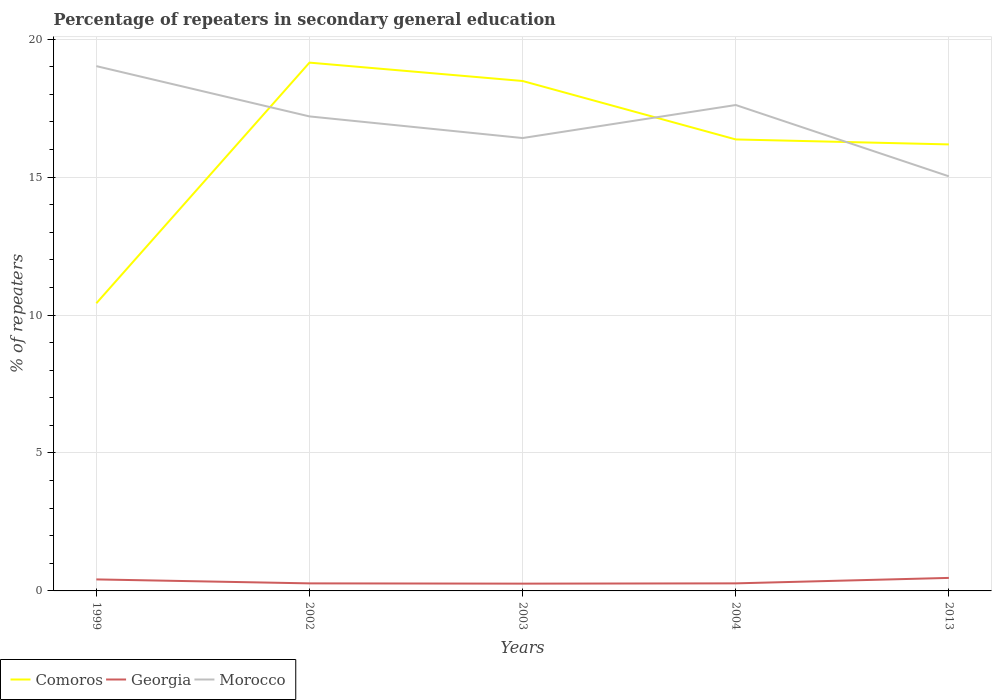Does the line corresponding to Georgia intersect with the line corresponding to Comoros?
Your response must be concise. No. Across all years, what is the maximum percentage of repeaters in secondary general education in Georgia?
Your answer should be compact. 0.26. What is the total percentage of repeaters in secondary general education in Georgia in the graph?
Provide a succinct answer. -0. What is the difference between the highest and the second highest percentage of repeaters in secondary general education in Georgia?
Make the answer very short. 0.21. How many years are there in the graph?
Offer a terse response. 5. Does the graph contain any zero values?
Make the answer very short. No. Does the graph contain grids?
Offer a terse response. Yes. Where does the legend appear in the graph?
Keep it short and to the point. Bottom left. How many legend labels are there?
Your answer should be compact. 3. What is the title of the graph?
Keep it short and to the point. Percentage of repeaters in secondary general education. Does "Albania" appear as one of the legend labels in the graph?
Provide a short and direct response. No. What is the label or title of the Y-axis?
Ensure brevity in your answer.  % of repeaters. What is the % of repeaters in Comoros in 1999?
Provide a succinct answer. 10.43. What is the % of repeaters in Georgia in 1999?
Offer a terse response. 0.42. What is the % of repeaters in Morocco in 1999?
Your answer should be compact. 19.02. What is the % of repeaters of Comoros in 2002?
Your answer should be compact. 19.15. What is the % of repeaters of Georgia in 2002?
Offer a terse response. 0.27. What is the % of repeaters in Morocco in 2002?
Your answer should be compact. 17.2. What is the % of repeaters of Comoros in 2003?
Give a very brief answer. 18.49. What is the % of repeaters of Georgia in 2003?
Give a very brief answer. 0.26. What is the % of repeaters in Morocco in 2003?
Give a very brief answer. 16.42. What is the % of repeaters of Comoros in 2004?
Provide a succinct answer. 16.37. What is the % of repeaters of Georgia in 2004?
Your answer should be very brief. 0.27. What is the % of repeaters in Morocco in 2004?
Make the answer very short. 17.61. What is the % of repeaters of Comoros in 2013?
Provide a short and direct response. 16.19. What is the % of repeaters in Georgia in 2013?
Provide a short and direct response. 0.47. What is the % of repeaters in Morocco in 2013?
Offer a very short reply. 15.03. Across all years, what is the maximum % of repeaters of Comoros?
Offer a very short reply. 19.15. Across all years, what is the maximum % of repeaters in Georgia?
Make the answer very short. 0.47. Across all years, what is the maximum % of repeaters of Morocco?
Your answer should be very brief. 19.02. Across all years, what is the minimum % of repeaters in Comoros?
Your answer should be very brief. 10.43. Across all years, what is the minimum % of repeaters of Georgia?
Keep it short and to the point. 0.26. Across all years, what is the minimum % of repeaters of Morocco?
Ensure brevity in your answer.  15.03. What is the total % of repeaters of Comoros in the graph?
Offer a terse response. 80.62. What is the total % of repeaters in Georgia in the graph?
Make the answer very short. 1.7. What is the total % of repeaters of Morocco in the graph?
Ensure brevity in your answer.  85.29. What is the difference between the % of repeaters in Comoros in 1999 and that in 2002?
Keep it short and to the point. -8.72. What is the difference between the % of repeaters of Georgia in 1999 and that in 2002?
Keep it short and to the point. 0.14. What is the difference between the % of repeaters in Morocco in 1999 and that in 2002?
Offer a terse response. 1.82. What is the difference between the % of repeaters in Comoros in 1999 and that in 2003?
Your answer should be compact. -8.06. What is the difference between the % of repeaters of Georgia in 1999 and that in 2003?
Provide a short and direct response. 0.15. What is the difference between the % of repeaters in Morocco in 1999 and that in 2003?
Your response must be concise. 2.61. What is the difference between the % of repeaters in Comoros in 1999 and that in 2004?
Offer a terse response. -5.94. What is the difference between the % of repeaters of Georgia in 1999 and that in 2004?
Your response must be concise. 0.14. What is the difference between the % of repeaters in Morocco in 1999 and that in 2004?
Offer a terse response. 1.41. What is the difference between the % of repeaters of Comoros in 1999 and that in 2013?
Your answer should be compact. -5.76. What is the difference between the % of repeaters in Georgia in 1999 and that in 2013?
Your response must be concise. -0.05. What is the difference between the % of repeaters in Morocco in 1999 and that in 2013?
Your response must be concise. 4. What is the difference between the % of repeaters of Comoros in 2002 and that in 2003?
Offer a terse response. 0.67. What is the difference between the % of repeaters of Georgia in 2002 and that in 2003?
Offer a very short reply. 0.01. What is the difference between the % of repeaters of Morocco in 2002 and that in 2003?
Provide a short and direct response. 0.78. What is the difference between the % of repeaters in Comoros in 2002 and that in 2004?
Make the answer very short. 2.78. What is the difference between the % of repeaters in Georgia in 2002 and that in 2004?
Make the answer very short. -0. What is the difference between the % of repeaters of Morocco in 2002 and that in 2004?
Provide a succinct answer. -0.41. What is the difference between the % of repeaters of Comoros in 2002 and that in 2013?
Your answer should be compact. 2.96. What is the difference between the % of repeaters in Georgia in 2002 and that in 2013?
Keep it short and to the point. -0.2. What is the difference between the % of repeaters in Morocco in 2002 and that in 2013?
Your answer should be very brief. 2.17. What is the difference between the % of repeaters of Comoros in 2003 and that in 2004?
Make the answer very short. 2.12. What is the difference between the % of repeaters of Georgia in 2003 and that in 2004?
Provide a short and direct response. -0.01. What is the difference between the % of repeaters in Morocco in 2003 and that in 2004?
Offer a very short reply. -1.2. What is the difference between the % of repeaters of Comoros in 2003 and that in 2013?
Your response must be concise. 2.3. What is the difference between the % of repeaters in Georgia in 2003 and that in 2013?
Your answer should be compact. -0.21. What is the difference between the % of repeaters of Morocco in 2003 and that in 2013?
Make the answer very short. 1.39. What is the difference between the % of repeaters of Comoros in 2004 and that in 2013?
Your answer should be very brief. 0.18. What is the difference between the % of repeaters of Georgia in 2004 and that in 2013?
Give a very brief answer. -0.2. What is the difference between the % of repeaters of Morocco in 2004 and that in 2013?
Give a very brief answer. 2.58. What is the difference between the % of repeaters in Comoros in 1999 and the % of repeaters in Georgia in 2002?
Provide a succinct answer. 10.15. What is the difference between the % of repeaters of Comoros in 1999 and the % of repeaters of Morocco in 2002?
Your answer should be very brief. -6.77. What is the difference between the % of repeaters in Georgia in 1999 and the % of repeaters in Morocco in 2002?
Offer a terse response. -16.78. What is the difference between the % of repeaters in Comoros in 1999 and the % of repeaters in Georgia in 2003?
Offer a terse response. 10.16. What is the difference between the % of repeaters of Comoros in 1999 and the % of repeaters of Morocco in 2003?
Provide a short and direct response. -5.99. What is the difference between the % of repeaters of Georgia in 1999 and the % of repeaters of Morocco in 2003?
Offer a very short reply. -16. What is the difference between the % of repeaters in Comoros in 1999 and the % of repeaters in Georgia in 2004?
Offer a terse response. 10.15. What is the difference between the % of repeaters of Comoros in 1999 and the % of repeaters of Morocco in 2004?
Offer a very short reply. -7.19. What is the difference between the % of repeaters in Georgia in 1999 and the % of repeaters in Morocco in 2004?
Offer a very short reply. -17.2. What is the difference between the % of repeaters in Comoros in 1999 and the % of repeaters in Georgia in 2013?
Make the answer very short. 9.96. What is the difference between the % of repeaters in Comoros in 1999 and the % of repeaters in Morocco in 2013?
Keep it short and to the point. -4.6. What is the difference between the % of repeaters of Georgia in 1999 and the % of repeaters of Morocco in 2013?
Provide a short and direct response. -14.61. What is the difference between the % of repeaters in Comoros in 2002 and the % of repeaters in Georgia in 2003?
Ensure brevity in your answer.  18.89. What is the difference between the % of repeaters in Comoros in 2002 and the % of repeaters in Morocco in 2003?
Your response must be concise. 2.73. What is the difference between the % of repeaters of Georgia in 2002 and the % of repeaters of Morocco in 2003?
Give a very brief answer. -16.14. What is the difference between the % of repeaters of Comoros in 2002 and the % of repeaters of Georgia in 2004?
Ensure brevity in your answer.  18.88. What is the difference between the % of repeaters in Comoros in 2002 and the % of repeaters in Morocco in 2004?
Provide a succinct answer. 1.54. What is the difference between the % of repeaters of Georgia in 2002 and the % of repeaters of Morocco in 2004?
Your answer should be very brief. -17.34. What is the difference between the % of repeaters of Comoros in 2002 and the % of repeaters of Georgia in 2013?
Your answer should be very brief. 18.68. What is the difference between the % of repeaters of Comoros in 2002 and the % of repeaters of Morocco in 2013?
Your response must be concise. 4.12. What is the difference between the % of repeaters of Georgia in 2002 and the % of repeaters of Morocco in 2013?
Your answer should be very brief. -14.76. What is the difference between the % of repeaters of Comoros in 2003 and the % of repeaters of Georgia in 2004?
Keep it short and to the point. 18.21. What is the difference between the % of repeaters in Comoros in 2003 and the % of repeaters in Morocco in 2004?
Provide a succinct answer. 0.87. What is the difference between the % of repeaters in Georgia in 2003 and the % of repeaters in Morocco in 2004?
Offer a terse response. -17.35. What is the difference between the % of repeaters of Comoros in 2003 and the % of repeaters of Georgia in 2013?
Ensure brevity in your answer.  18.01. What is the difference between the % of repeaters in Comoros in 2003 and the % of repeaters in Morocco in 2013?
Offer a very short reply. 3.46. What is the difference between the % of repeaters of Georgia in 2003 and the % of repeaters of Morocco in 2013?
Keep it short and to the point. -14.77. What is the difference between the % of repeaters in Comoros in 2004 and the % of repeaters in Georgia in 2013?
Make the answer very short. 15.89. What is the difference between the % of repeaters of Comoros in 2004 and the % of repeaters of Morocco in 2013?
Provide a short and direct response. 1.34. What is the difference between the % of repeaters of Georgia in 2004 and the % of repeaters of Morocco in 2013?
Your answer should be compact. -14.76. What is the average % of repeaters in Comoros per year?
Your answer should be compact. 16.12. What is the average % of repeaters of Georgia per year?
Offer a terse response. 0.34. What is the average % of repeaters in Morocco per year?
Offer a very short reply. 17.06. In the year 1999, what is the difference between the % of repeaters of Comoros and % of repeaters of Georgia?
Ensure brevity in your answer.  10.01. In the year 1999, what is the difference between the % of repeaters in Comoros and % of repeaters in Morocco?
Offer a very short reply. -8.6. In the year 1999, what is the difference between the % of repeaters of Georgia and % of repeaters of Morocco?
Your response must be concise. -18.61. In the year 2002, what is the difference between the % of repeaters in Comoros and % of repeaters in Georgia?
Offer a terse response. 18.88. In the year 2002, what is the difference between the % of repeaters in Comoros and % of repeaters in Morocco?
Ensure brevity in your answer.  1.95. In the year 2002, what is the difference between the % of repeaters of Georgia and % of repeaters of Morocco?
Your answer should be compact. -16.93. In the year 2003, what is the difference between the % of repeaters of Comoros and % of repeaters of Georgia?
Offer a very short reply. 18.22. In the year 2003, what is the difference between the % of repeaters in Comoros and % of repeaters in Morocco?
Offer a very short reply. 2.07. In the year 2003, what is the difference between the % of repeaters in Georgia and % of repeaters in Morocco?
Make the answer very short. -16.15. In the year 2004, what is the difference between the % of repeaters of Comoros and % of repeaters of Georgia?
Give a very brief answer. 16.09. In the year 2004, what is the difference between the % of repeaters in Comoros and % of repeaters in Morocco?
Ensure brevity in your answer.  -1.25. In the year 2004, what is the difference between the % of repeaters in Georgia and % of repeaters in Morocco?
Give a very brief answer. -17.34. In the year 2013, what is the difference between the % of repeaters in Comoros and % of repeaters in Georgia?
Offer a very short reply. 15.71. In the year 2013, what is the difference between the % of repeaters of Comoros and % of repeaters of Morocco?
Offer a very short reply. 1.16. In the year 2013, what is the difference between the % of repeaters of Georgia and % of repeaters of Morocco?
Your answer should be very brief. -14.56. What is the ratio of the % of repeaters in Comoros in 1999 to that in 2002?
Ensure brevity in your answer.  0.54. What is the ratio of the % of repeaters of Georgia in 1999 to that in 2002?
Offer a very short reply. 1.53. What is the ratio of the % of repeaters of Morocco in 1999 to that in 2002?
Keep it short and to the point. 1.11. What is the ratio of the % of repeaters in Comoros in 1999 to that in 2003?
Your answer should be compact. 0.56. What is the ratio of the % of repeaters in Georgia in 1999 to that in 2003?
Offer a very short reply. 1.58. What is the ratio of the % of repeaters in Morocco in 1999 to that in 2003?
Provide a short and direct response. 1.16. What is the ratio of the % of repeaters in Comoros in 1999 to that in 2004?
Offer a terse response. 0.64. What is the ratio of the % of repeaters in Georgia in 1999 to that in 2004?
Your answer should be very brief. 1.52. What is the ratio of the % of repeaters in Morocco in 1999 to that in 2004?
Make the answer very short. 1.08. What is the ratio of the % of repeaters in Comoros in 1999 to that in 2013?
Provide a short and direct response. 0.64. What is the ratio of the % of repeaters in Georgia in 1999 to that in 2013?
Your answer should be compact. 0.88. What is the ratio of the % of repeaters in Morocco in 1999 to that in 2013?
Ensure brevity in your answer.  1.27. What is the ratio of the % of repeaters of Comoros in 2002 to that in 2003?
Offer a very short reply. 1.04. What is the ratio of the % of repeaters of Georgia in 2002 to that in 2003?
Keep it short and to the point. 1.04. What is the ratio of the % of repeaters of Morocco in 2002 to that in 2003?
Provide a short and direct response. 1.05. What is the ratio of the % of repeaters of Comoros in 2002 to that in 2004?
Keep it short and to the point. 1.17. What is the ratio of the % of repeaters of Georgia in 2002 to that in 2004?
Your answer should be compact. 1. What is the ratio of the % of repeaters of Morocco in 2002 to that in 2004?
Your response must be concise. 0.98. What is the ratio of the % of repeaters in Comoros in 2002 to that in 2013?
Offer a very short reply. 1.18. What is the ratio of the % of repeaters of Georgia in 2002 to that in 2013?
Your answer should be compact. 0.58. What is the ratio of the % of repeaters of Morocco in 2002 to that in 2013?
Ensure brevity in your answer.  1.14. What is the ratio of the % of repeaters in Comoros in 2003 to that in 2004?
Offer a terse response. 1.13. What is the ratio of the % of repeaters in Morocco in 2003 to that in 2004?
Ensure brevity in your answer.  0.93. What is the ratio of the % of repeaters of Comoros in 2003 to that in 2013?
Provide a succinct answer. 1.14. What is the ratio of the % of repeaters in Georgia in 2003 to that in 2013?
Ensure brevity in your answer.  0.56. What is the ratio of the % of repeaters in Morocco in 2003 to that in 2013?
Make the answer very short. 1.09. What is the ratio of the % of repeaters in Comoros in 2004 to that in 2013?
Provide a succinct answer. 1.01. What is the ratio of the % of repeaters of Georgia in 2004 to that in 2013?
Make the answer very short. 0.58. What is the ratio of the % of repeaters of Morocco in 2004 to that in 2013?
Your answer should be compact. 1.17. What is the difference between the highest and the second highest % of repeaters in Comoros?
Offer a terse response. 0.67. What is the difference between the highest and the second highest % of repeaters of Georgia?
Provide a succinct answer. 0.05. What is the difference between the highest and the second highest % of repeaters in Morocco?
Keep it short and to the point. 1.41. What is the difference between the highest and the lowest % of repeaters of Comoros?
Make the answer very short. 8.72. What is the difference between the highest and the lowest % of repeaters of Georgia?
Provide a short and direct response. 0.21. What is the difference between the highest and the lowest % of repeaters in Morocco?
Your response must be concise. 4. 